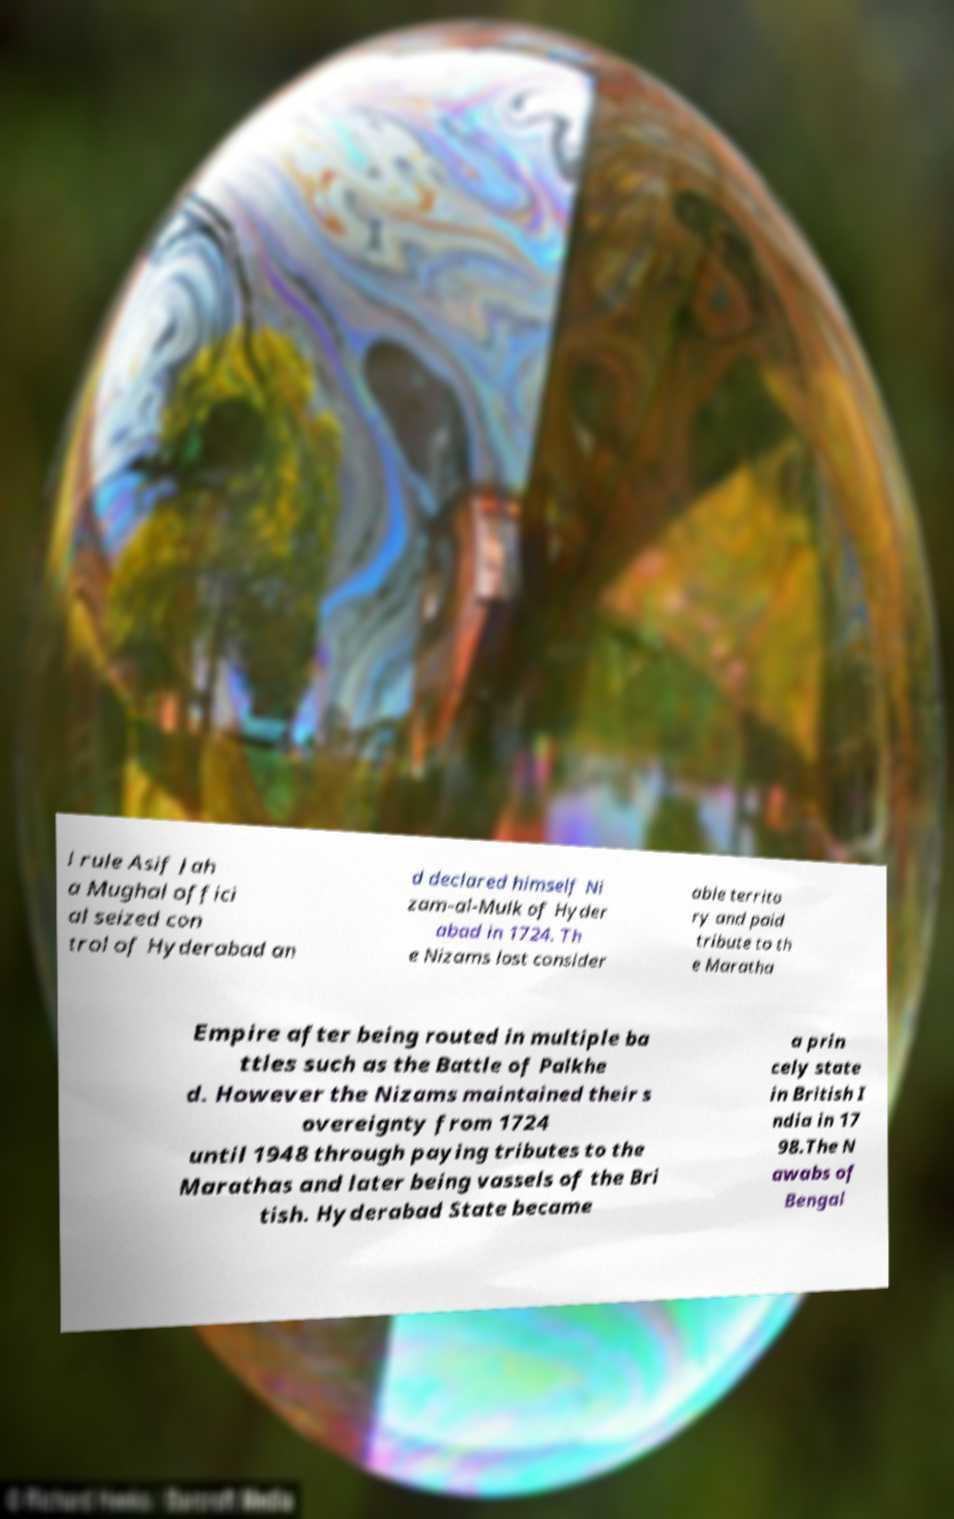Please identify and transcribe the text found in this image. l rule Asif Jah a Mughal offici al seized con trol of Hyderabad an d declared himself Ni zam-al-Mulk of Hyder abad in 1724. Th e Nizams lost consider able territo ry and paid tribute to th e Maratha Empire after being routed in multiple ba ttles such as the Battle of Palkhe d. However the Nizams maintained their s overeignty from 1724 until 1948 through paying tributes to the Marathas and later being vassels of the Bri tish. Hyderabad State became a prin cely state in British I ndia in 17 98.The N awabs of Bengal 